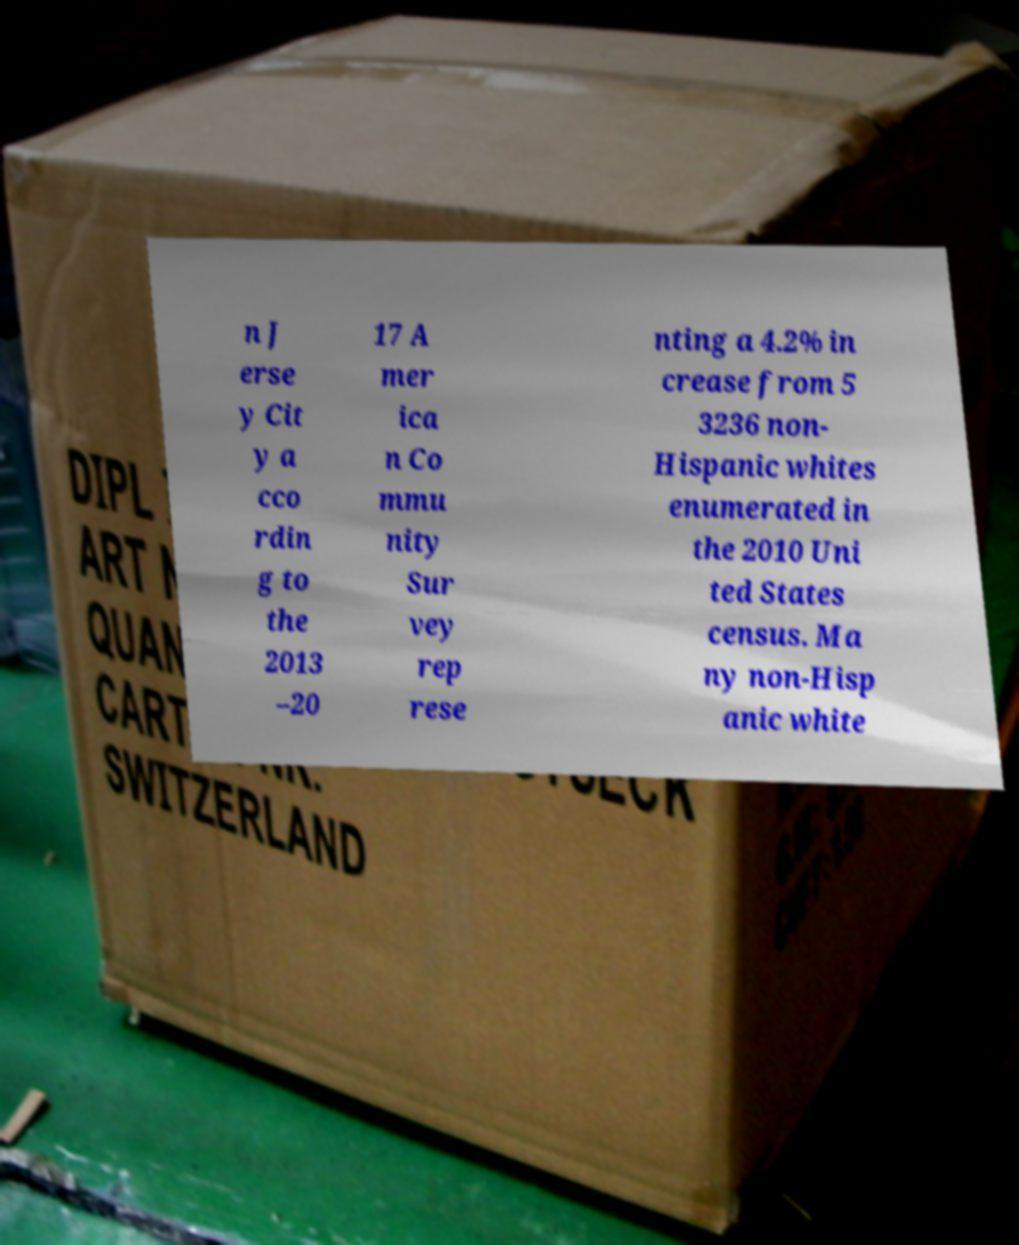Can you read and provide the text displayed in the image?This photo seems to have some interesting text. Can you extract and type it out for me? n J erse y Cit y a cco rdin g to the 2013 –20 17 A mer ica n Co mmu nity Sur vey rep rese nting a 4.2% in crease from 5 3236 non- Hispanic whites enumerated in the 2010 Uni ted States census. Ma ny non-Hisp anic white 